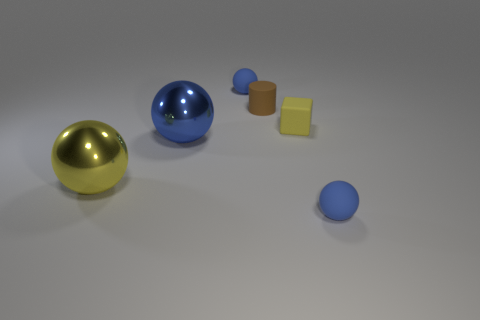What is the size of the brown object that is made of the same material as the tiny yellow cube?
Offer a very short reply. Small. Is the number of small yellow rubber objects less than the number of yellow things?
Provide a short and direct response. Yes. The yellow thing that is to the left of the small brown rubber cylinder that is to the left of the small blue ball that is in front of the yellow block is made of what material?
Give a very brief answer. Metal. Is the material of the yellow block that is behind the yellow sphere the same as the ball that is behind the blue shiny thing?
Your answer should be very brief. Yes. There is a ball that is to the left of the tiny matte block and in front of the large blue metallic thing; how big is it?
Provide a short and direct response. Large. What material is the block that is the same size as the brown rubber object?
Offer a very short reply. Rubber. There is a tiny ball that is in front of the blue shiny sphere left of the brown thing; what number of metallic objects are behind it?
Keep it short and to the point. 2. There is a small rubber ball that is in front of the brown rubber object; is its color the same as the big metal object that is to the right of the big yellow object?
Your response must be concise. Yes. What color is the object that is in front of the blue shiny object and left of the small matte cube?
Provide a short and direct response. Yellow. How many blue objects are the same size as the yellow shiny thing?
Provide a short and direct response. 1. 